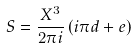Convert formula to latex. <formula><loc_0><loc_0><loc_500><loc_500>S = \frac { X ^ { 3 } } { 2 \pi i } \left ( i \pi d + e \right )</formula> 